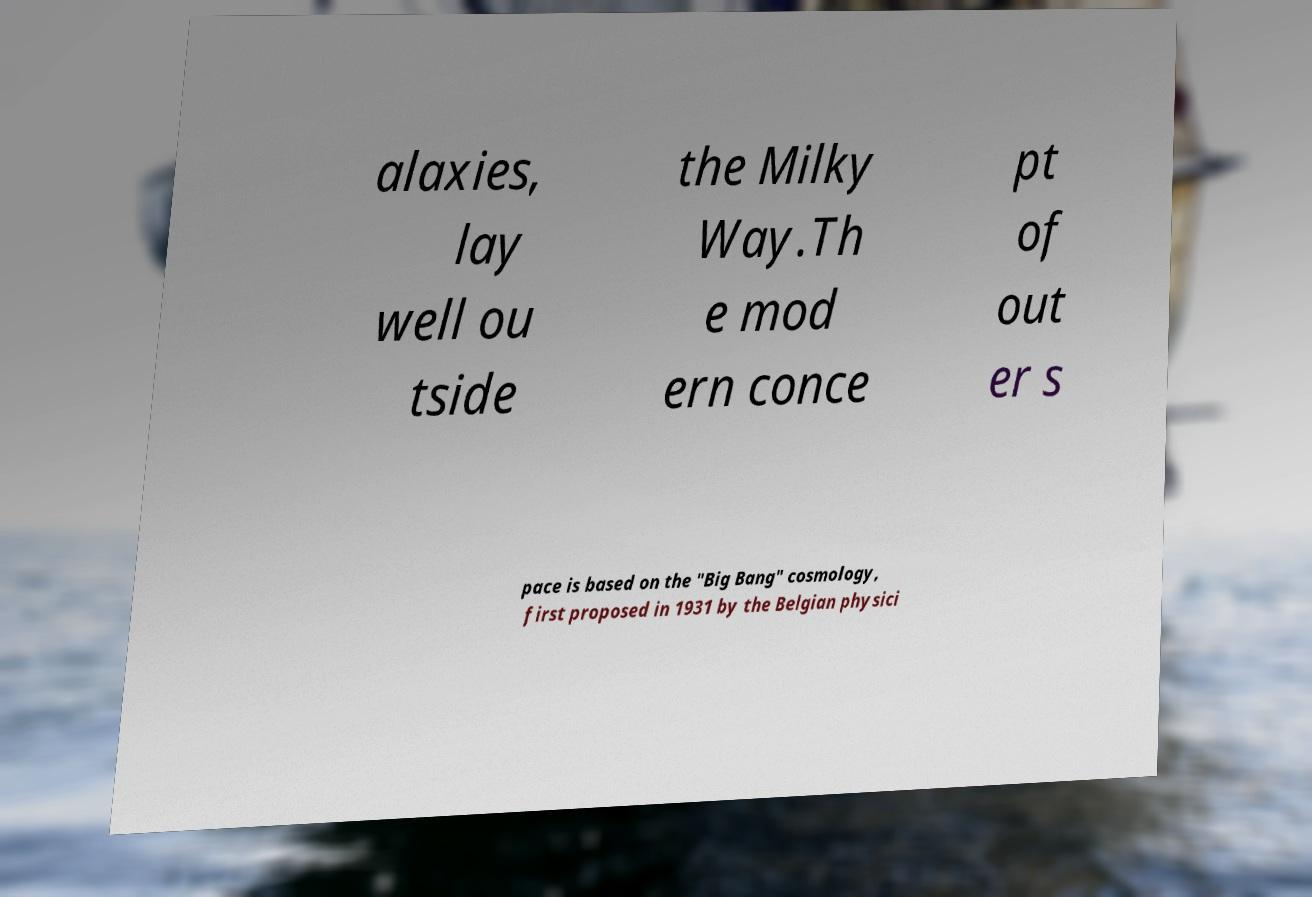I need the written content from this picture converted into text. Can you do that? alaxies, lay well ou tside the Milky Way.Th e mod ern conce pt of out er s pace is based on the "Big Bang" cosmology, first proposed in 1931 by the Belgian physici 